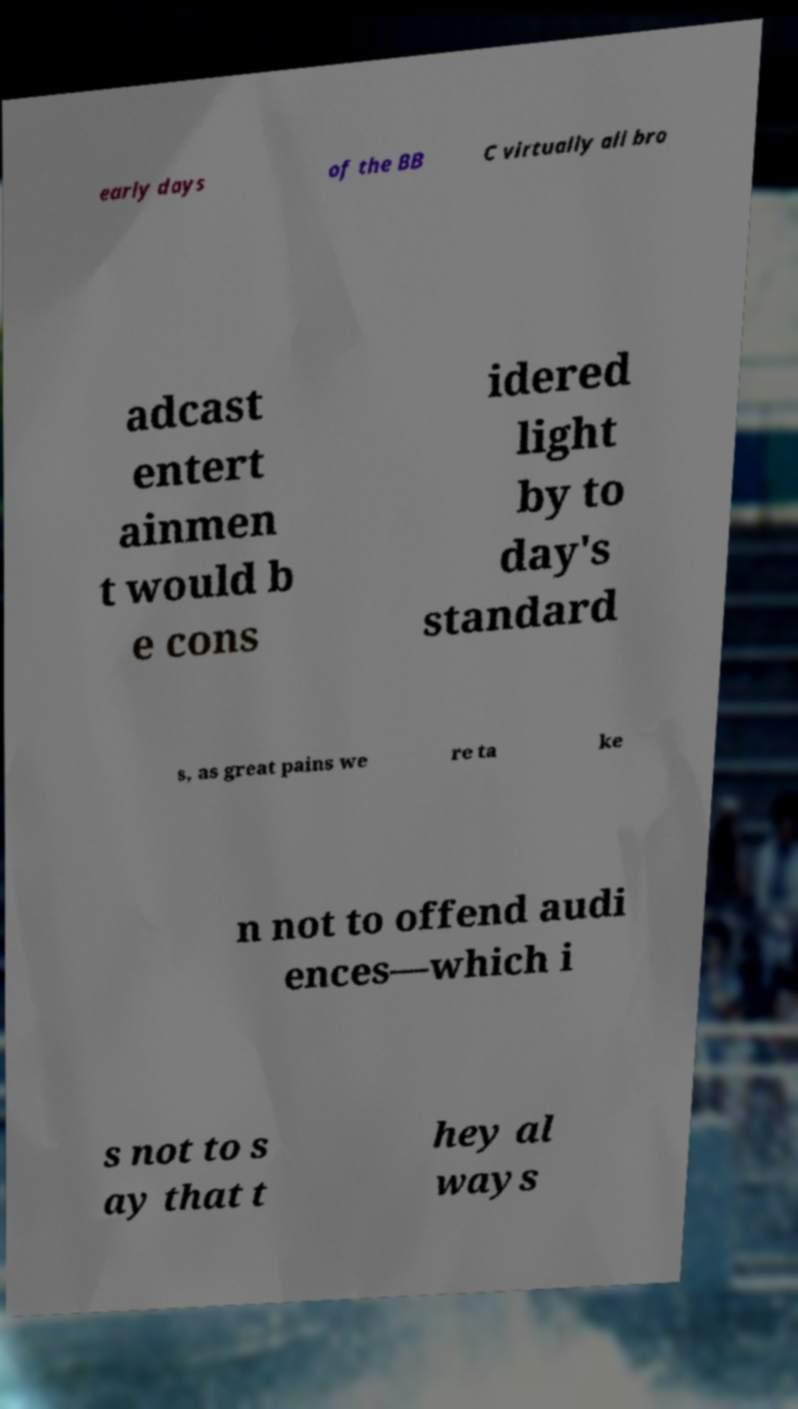There's text embedded in this image that I need extracted. Can you transcribe it verbatim? early days of the BB C virtually all bro adcast entert ainmen t would b e cons idered light by to day's standard s, as great pains we re ta ke n not to offend audi ences—which i s not to s ay that t hey al ways 